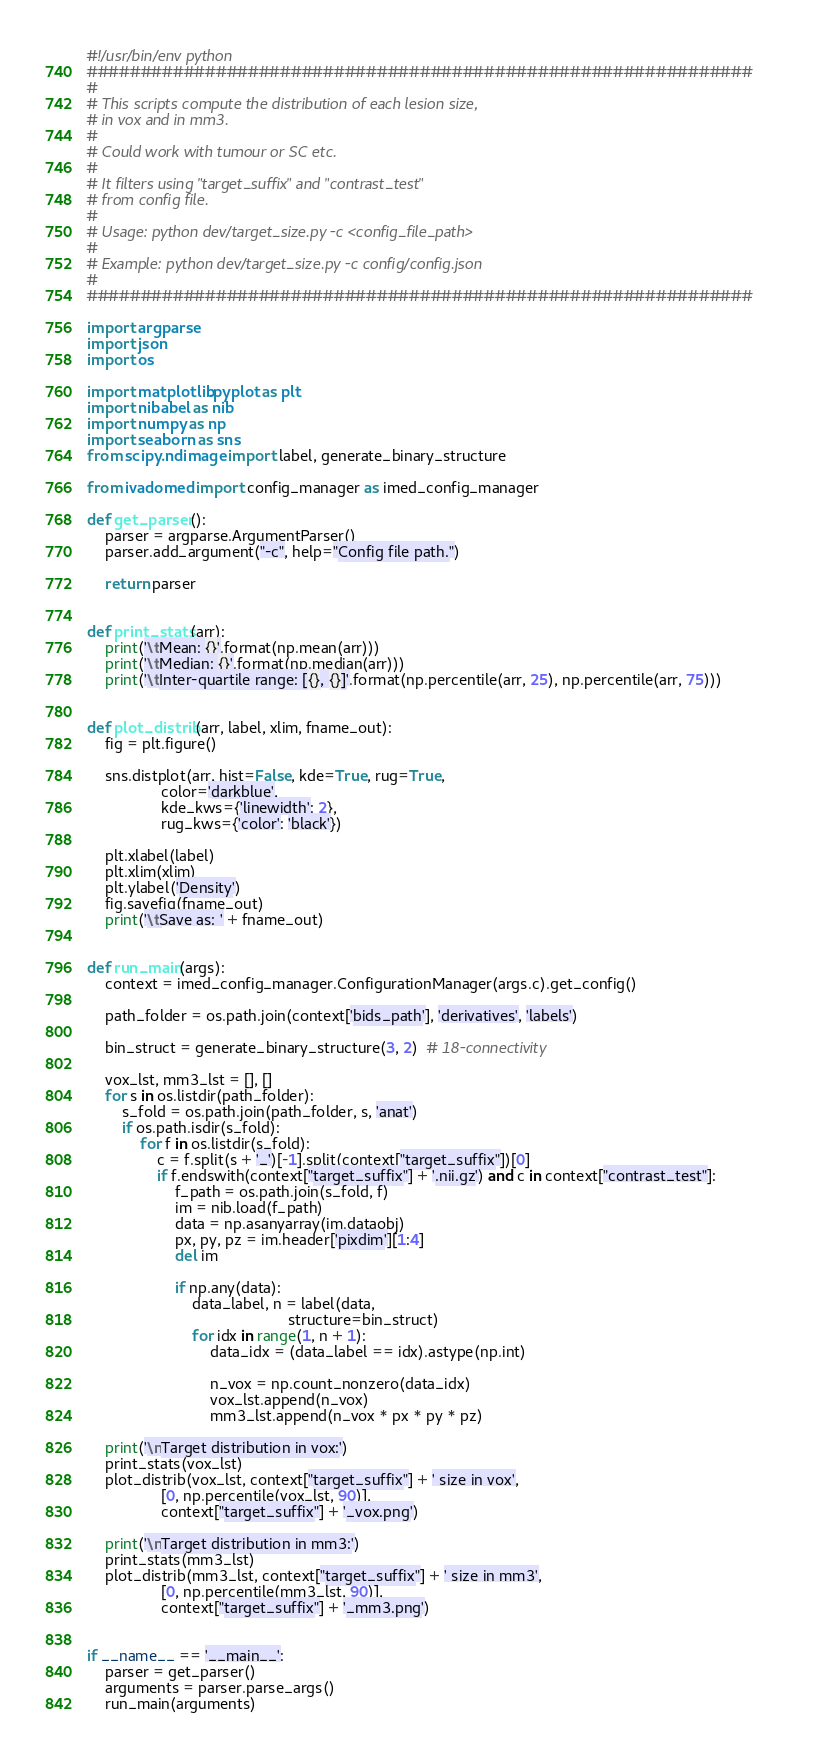<code> <loc_0><loc_0><loc_500><loc_500><_Python_>#!/usr/bin/env python
##############################################################
#
# This scripts compute the distribution of each lesion size,
# in vox and in mm3.
#
# Could work with tumour or SC etc.
#
# It filters using "target_suffix" and "contrast_test"
# from config file.
#
# Usage: python dev/target_size.py -c <config_file_path>
#
# Example: python dev/target_size.py -c config/config.json
#
##############################################################

import argparse
import json
import os

import matplotlib.pyplot as plt
import nibabel as nib
import numpy as np
import seaborn as sns
from scipy.ndimage import label, generate_binary_structure

from ivadomed import config_manager as imed_config_manager

def get_parser():
    parser = argparse.ArgumentParser()
    parser.add_argument("-c", help="Config file path.")

    return parser


def print_stats(arr):
    print('\tMean: {}'.format(np.mean(arr)))
    print('\tMedian: {}'.format(np.median(arr)))
    print('\tInter-quartile range: [{}, {}]'.format(np.percentile(arr, 25), np.percentile(arr, 75)))


def plot_distrib(arr, label, xlim, fname_out):
    fig = plt.figure()

    sns.distplot(arr, hist=False, kde=True, rug=True,
                 color='darkblue',
                 kde_kws={'linewidth': 2},
                 rug_kws={'color': 'black'})

    plt.xlabel(label)
    plt.xlim(xlim)
    plt.ylabel('Density')
    fig.savefig(fname_out)
    print('\tSave as: ' + fname_out)


def run_main(args):
    context = imed_config_manager.ConfigurationManager(args.c).get_config()

    path_folder = os.path.join(context['bids_path'], 'derivatives', 'labels')

    bin_struct = generate_binary_structure(3, 2)  # 18-connectivity

    vox_lst, mm3_lst = [], []
    for s in os.listdir(path_folder):
        s_fold = os.path.join(path_folder, s, 'anat')
        if os.path.isdir(s_fold):
            for f in os.listdir(s_fold):
                c = f.split(s + '_')[-1].split(context["target_suffix"])[0]
                if f.endswith(context["target_suffix"] + '.nii.gz') and c in context["contrast_test"]:
                    f_path = os.path.join(s_fold, f)
                    im = nib.load(f_path)
                    data = np.asanyarray(im.dataobj)
                    px, py, pz = im.header['pixdim'][1:4]
                    del im

                    if np.any(data):
                        data_label, n = label(data,
                                              structure=bin_struct)
                        for idx in range(1, n + 1):
                            data_idx = (data_label == idx).astype(np.int)

                            n_vox = np.count_nonzero(data_idx)
                            vox_lst.append(n_vox)
                            mm3_lst.append(n_vox * px * py * pz)

    print('\nTarget distribution in vox:')
    print_stats(vox_lst)
    plot_distrib(vox_lst, context["target_suffix"] + ' size in vox',
                 [0, np.percentile(vox_lst, 90)],
                 context["target_suffix"] + '_vox.png')

    print('\nTarget distribution in mm3:')
    print_stats(mm3_lst)
    plot_distrib(mm3_lst, context["target_suffix"] + ' size in mm3',
                 [0, np.percentile(mm3_lst, 90)],
                 context["target_suffix"] + '_mm3.png')


if __name__ == '__main__':
    parser = get_parser()
    arguments = parser.parse_args()
    run_main(arguments)
</code> 